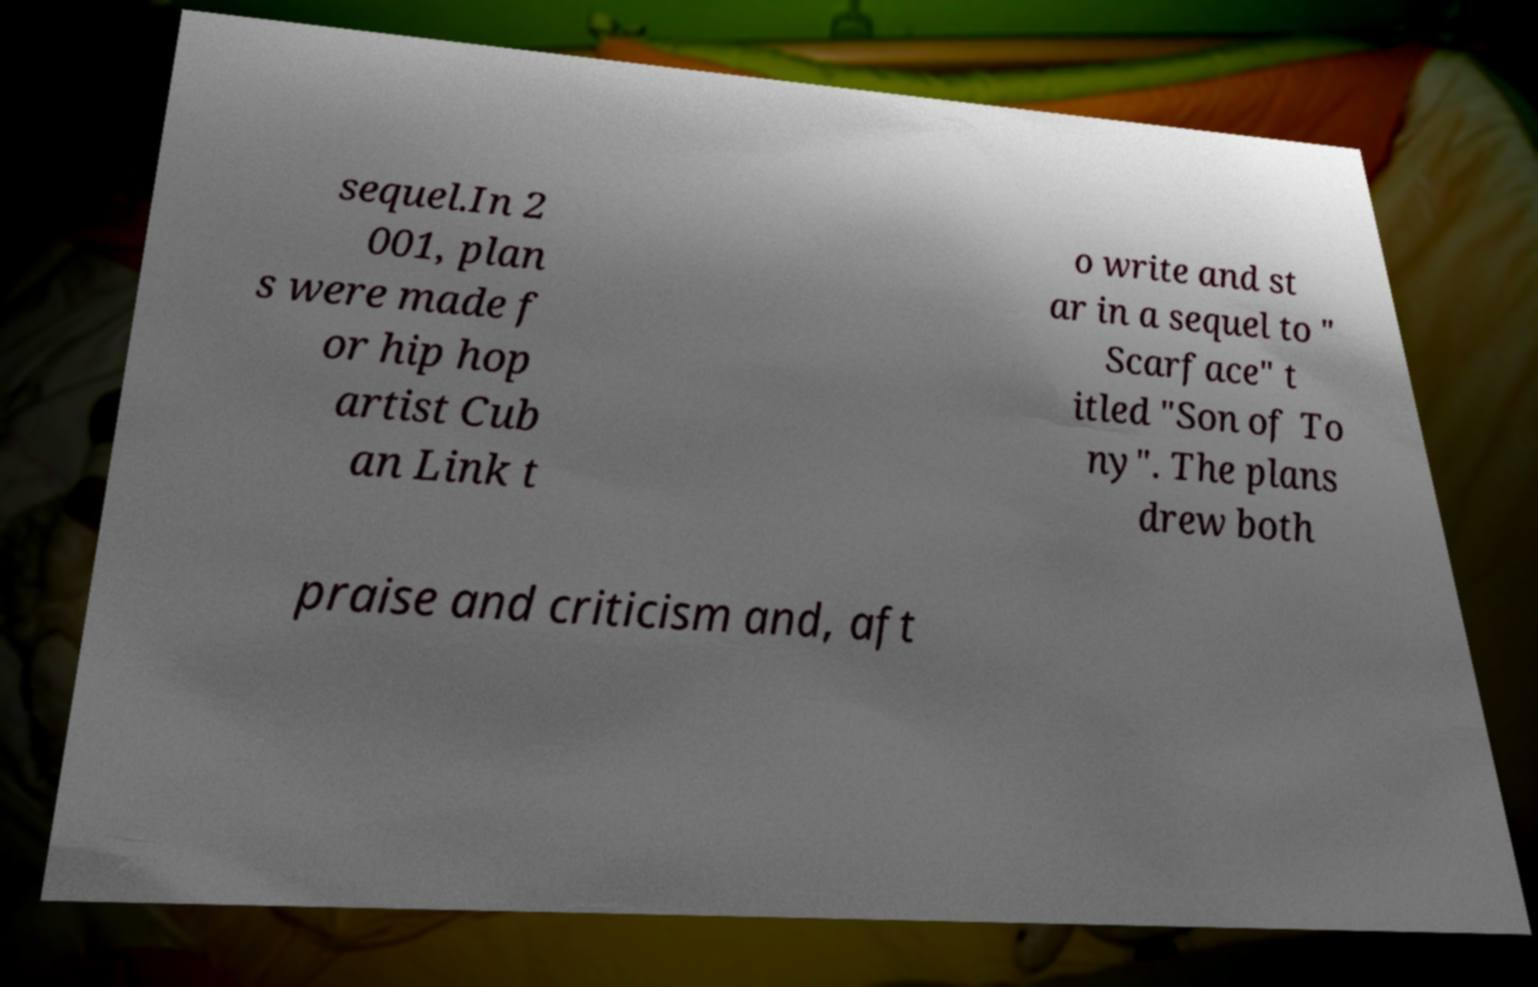Please read and relay the text visible in this image. What does it say? sequel.In 2 001, plan s were made f or hip hop artist Cub an Link t o write and st ar in a sequel to " Scarface" t itled "Son of To ny". The plans drew both praise and criticism and, aft 